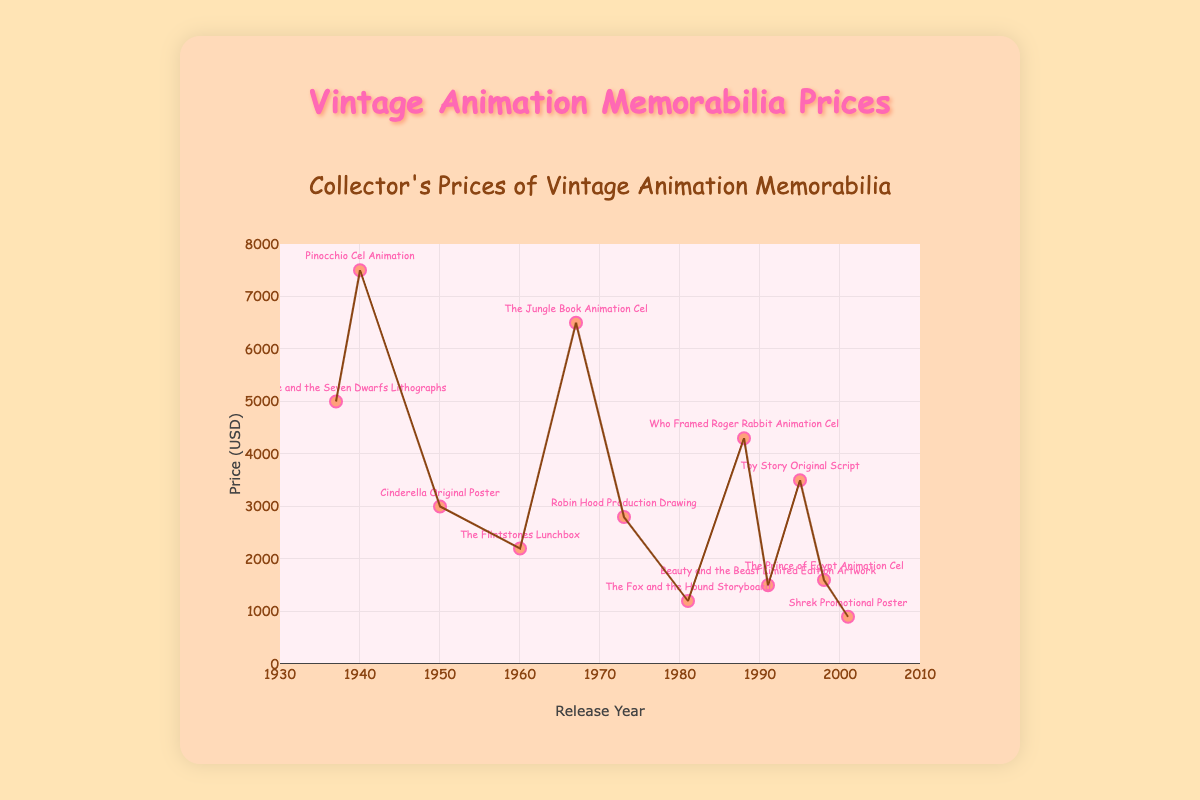What is the most expensive memorabilia item displayed in the figure? The most expensive item has the highest y-value on the plot, representing the price in USD. The Pinocchio Cel Animation from 1940 has a price of $7500, which is the highest among all items.
Answer: Pinocchio Cel Animation In what year was the Shrek Promotional Poster released, and what is its price? Locate the data point labeled "Shrek Promotional Poster" and check the corresponding x and y values for release year and price. This point is at x=2001 and y=900.
Answer: 2001, $900 How does the price of Toy Story Original Script compare to Beauty and the Beast Limited Edition Artwork? Find both data points on the plot and compare their y-values. The Toy Story Original Script from 1995 is at $3500, while the Beauty and the Beast Limited Edition Artwork from 1991 is at $1500. Toy Story is more expensive.
Answer: Toy Story is more expensive Which memorabilia items have prices higher than $5000 and were released before 1970? Identify the data points above the y-value of $5000 and check their x-values to ensure they are before 1970. These items are the Snow White and the Seven Dwarfs Lithographs from 1937, Pinocchio Cel Animation from 1940, and The Jungle Book Animation Cel from 1967.
Answer: Snow White and the Seven Dwarfs Lithographs, Pinocchio Cel Animation, The Jungle Book Animation Cel What is the range of release years of the memorabilia in the figure? Determine the earliest and latest years on the x-axis where data points exist. The earliest release year is 1937 and the latest is 2001. The range is from 1937 to 2001.
Answer: 1937 to 2001 What is the average price of the memorabilia items released in the 1990s? Identify the items released in the 1990s (1991, 1995, and 1998) and calculate the average of their prices. The prices are $1500, $3500, and $1600. Sum these prices (1500 + 3500 + 1600 = 6600) and divide by the number of items (3). The average price is 6600 / 3.
Answer: $2200 Which release year has the largest number of memorabilia items, and how many? Count the occurrences of each release year among the data points. Each year has a unique item with one count, so no year has more than one item.
Answer: Each year has one If you collect one item from each decade shown, what is the total price? Identify the decades covered (1930s to 2000s) and select one item per decade, then sum their prices. Items are Snow White and the Seven Dwarfs Lithographs ($5000), Cinderella Original Poster ($3000), The Flintstones Lunchbox ($2200), Robin Hood Production Drawing ($2800), Who Framed Roger Rabbit Animation Cel ($4300), and Shrek Promotional Poster ($900). The total price is ($5000 + $3000 + $2200 + $2800 + $4300 + $900).
Answer: $18200 Do older memorabilia items tend to be more expensive? Examine the trend line on the scatter plot, which gives a general direction of how prices change with release years. The trend shows that older items (left side) generally have higher prices than newer items (right side).
Answer: Yes 